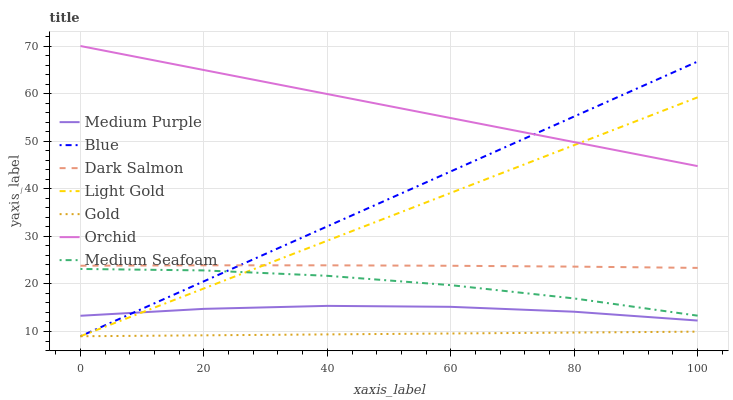Does Gold have the minimum area under the curve?
Answer yes or no. Yes. Does Orchid have the maximum area under the curve?
Answer yes or no. Yes. Does Dark Salmon have the minimum area under the curve?
Answer yes or no. No. Does Dark Salmon have the maximum area under the curve?
Answer yes or no. No. Is Gold the smoothest?
Answer yes or no. Yes. Is Medium Seafoam the roughest?
Answer yes or no. Yes. Is Dark Salmon the smoothest?
Answer yes or no. No. Is Dark Salmon the roughest?
Answer yes or no. No. Does Blue have the lowest value?
Answer yes or no. Yes. Does Dark Salmon have the lowest value?
Answer yes or no. No. Does Orchid have the highest value?
Answer yes or no. Yes. Does Dark Salmon have the highest value?
Answer yes or no. No. Is Medium Seafoam less than Dark Salmon?
Answer yes or no. Yes. Is Dark Salmon greater than Medium Seafoam?
Answer yes or no. Yes. Does Dark Salmon intersect Blue?
Answer yes or no. Yes. Is Dark Salmon less than Blue?
Answer yes or no. No. Is Dark Salmon greater than Blue?
Answer yes or no. No. Does Medium Seafoam intersect Dark Salmon?
Answer yes or no. No. 